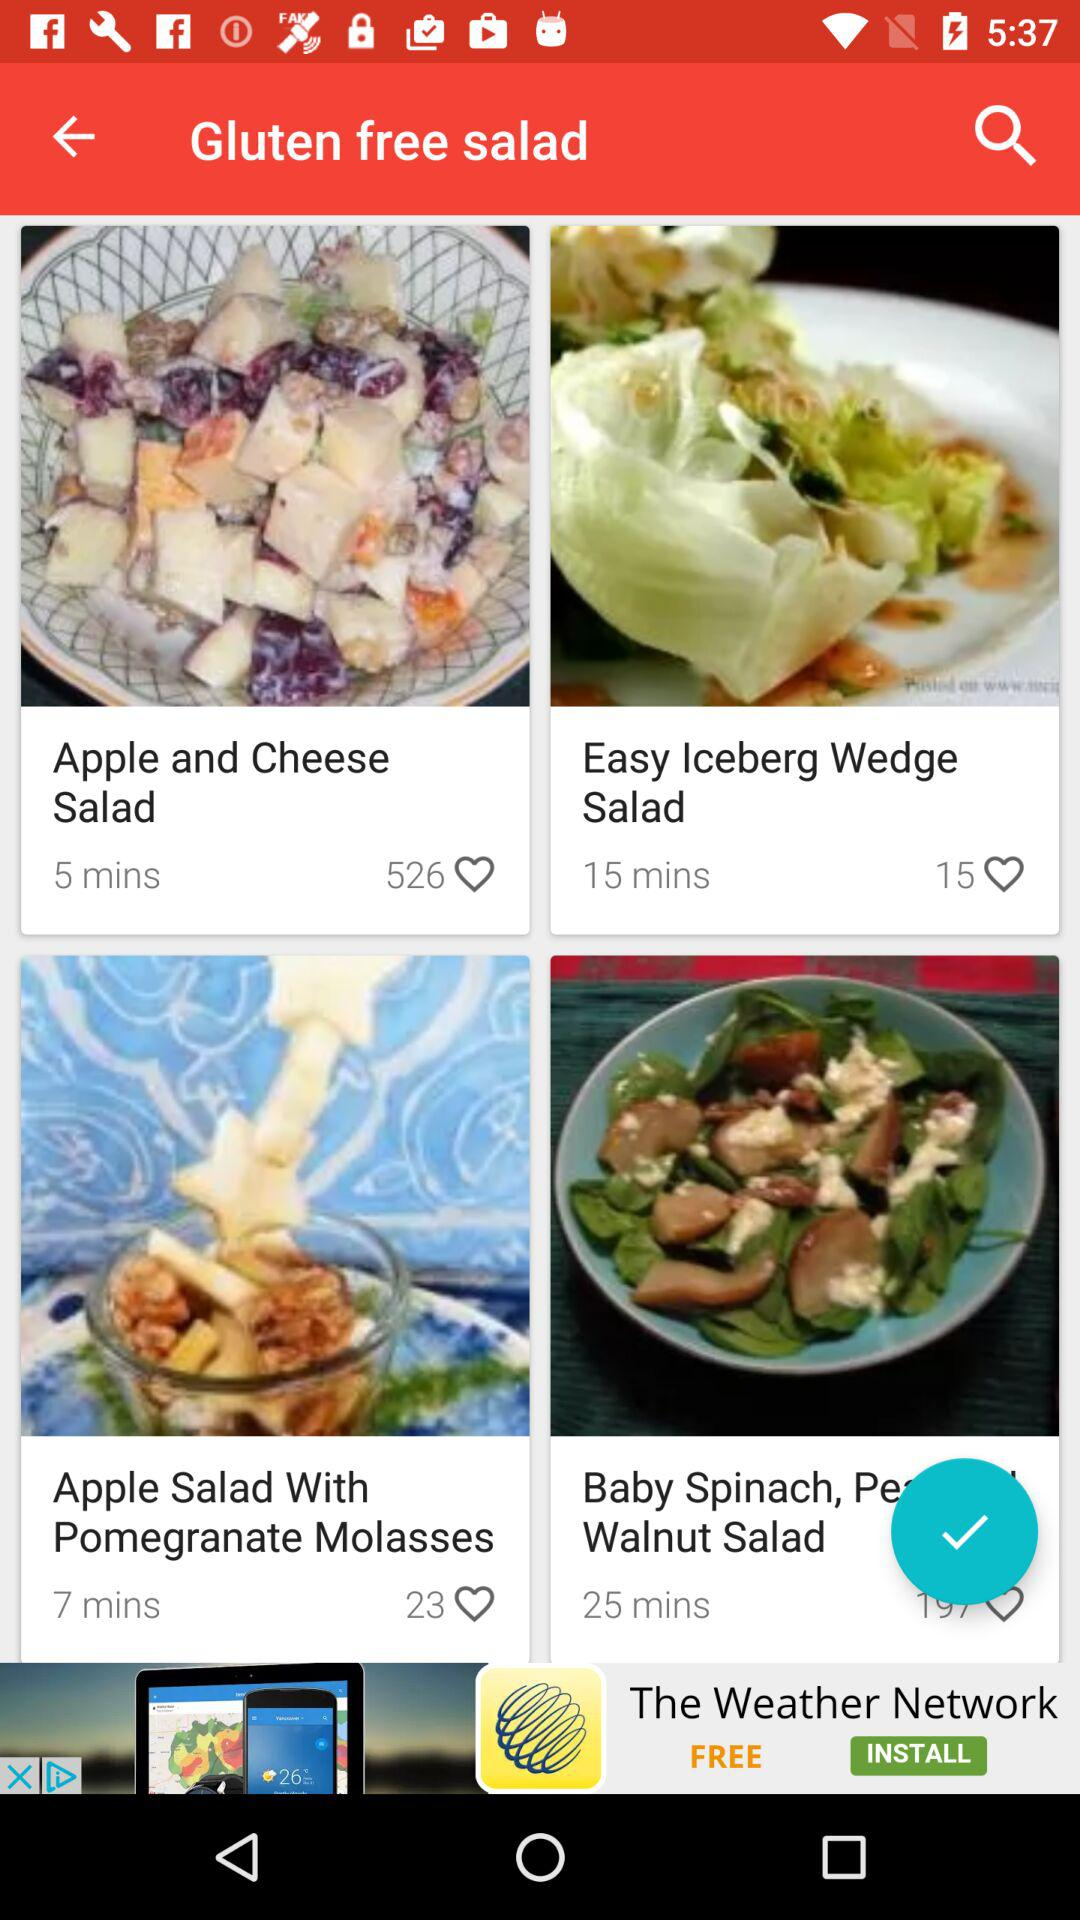How long will it take to deliver the apple salad with pomegranate molasses?
When the provided information is insufficient, respond with <no answer>. <no answer> 